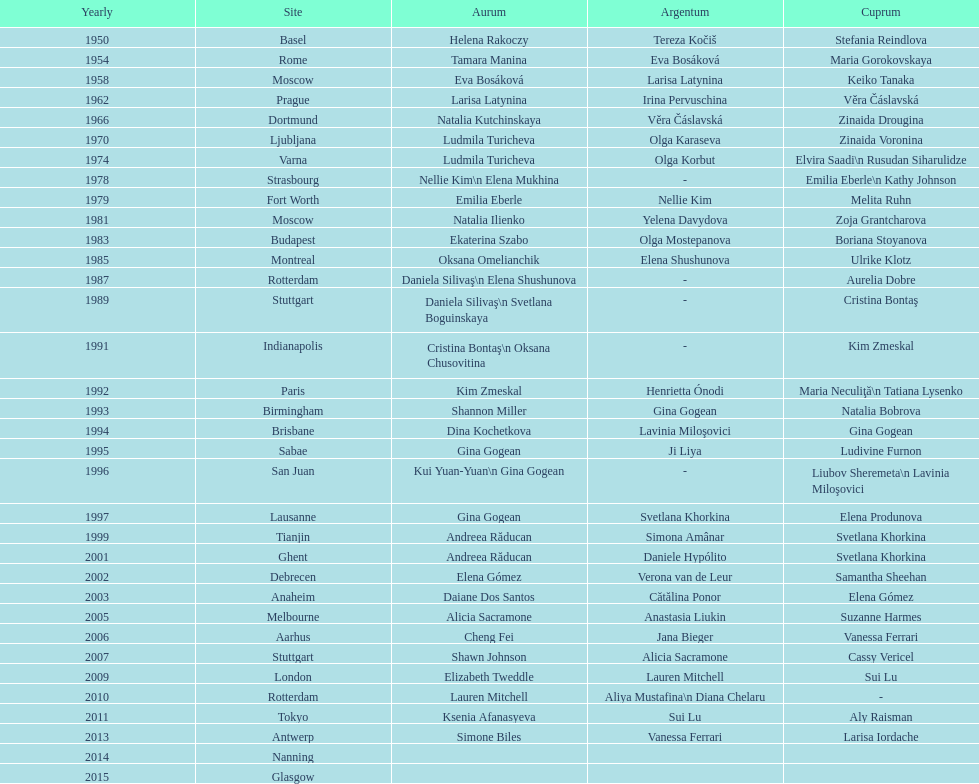Which two american rivals won consecutive floor exercise gold medals at the artistic gymnastics world championships in 1992 and 1993? Kim Zmeskal, Shannon Miller. 